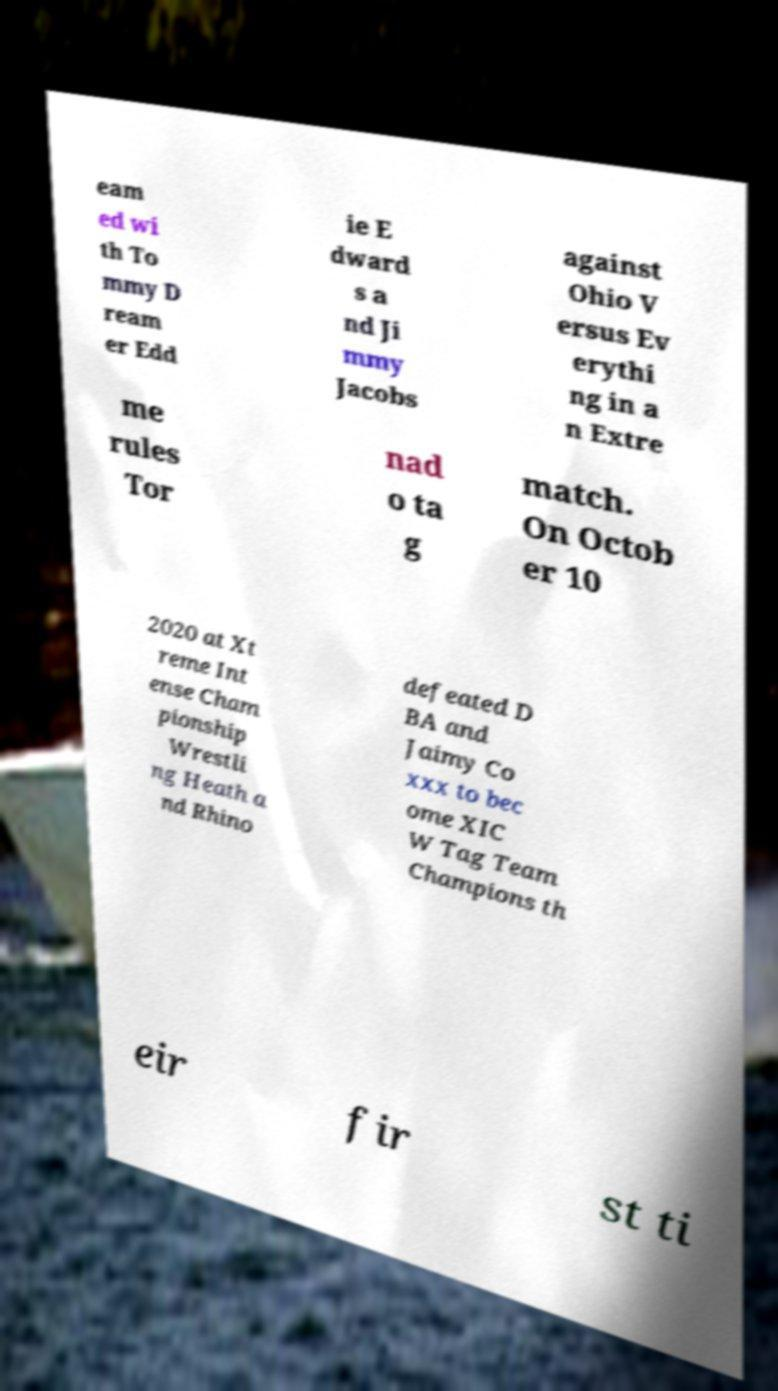Can you read and provide the text displayed in the image?This photo seems to have some interesting text. Can you extract and type it out for me? eam ed wi th To mmy D ream er Edd ie E dward s a nd Ji mmy Jacobs against Ohio V ersus Ev erythi ng in a n Extre me rules Tor nad o ta g match. On Octob er 10 2020 at Xt reme Int ense Cham pionship Wrestli ng Heath a nd Rhino defeated D BA and Jaimy Co xxx to bec ome XIC W Tag Team Champions th eir fir st ti 